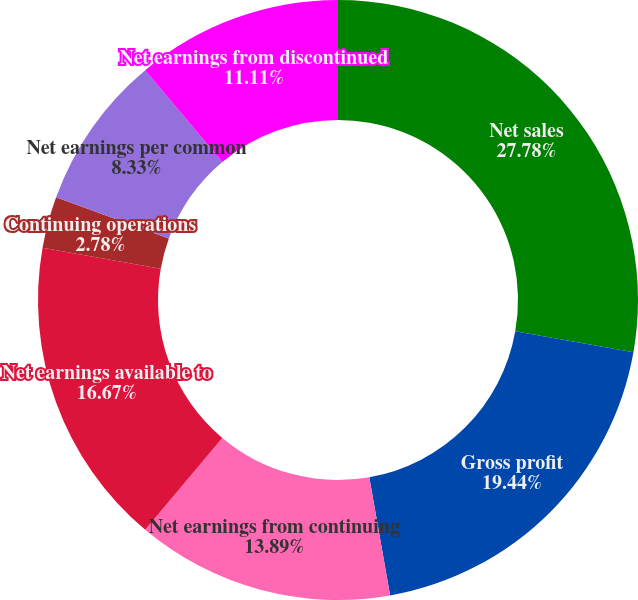Convert chart to OTSL. <chart><loc_0><loc_0><loc_500><loc_500><pie_chart><fcel>Net sales<fcel>Gross profit<fcel>Net earnings from continuing<fcel>Net earnings available to<fcel>Continuing operations<fcel>Net earnings per common<fcel>Net earnings from discontinued<fcel>Discontinued operations<nl><fcel>27.78%<fcel>19.44%<fcel>13.89%<fcel>16.67%<fcel>2.78%<fcel>8.33%<fcel>11.11%<fcel>0.0%<nl></chart> 